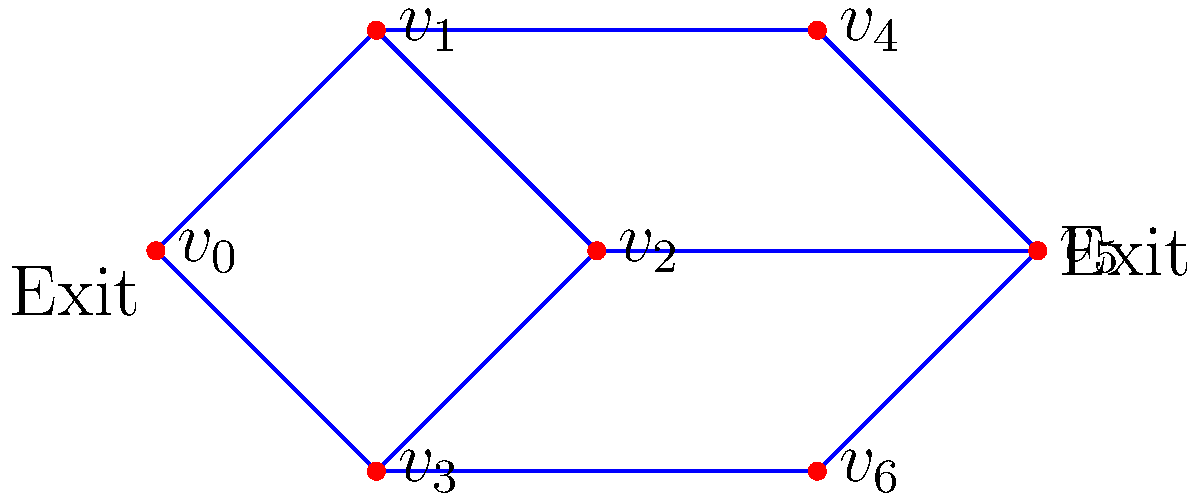Given the graph representing a shopping mall layout, where vertices represent intersections and edges represent corridors, determine the edge connectivity of the graph. How many edges need to be removed to disconnect the two emergency exits (located at $v_0$ and $v_5$)? Suggest one improvement to increase the mall's safety based on this analysis. To solve this problem, we'll follow these steps:

1. Identify the emergency exits: $v_0$ and $v_5$.

2. Determine the edge connectivity of the graph:
   - The edge connectivity is the minimum number of edges that need to be removed to disconnect the graph.
   - In this case, removing edges $(v_1, v_2)$ and $(v_2, v_5)$ would disconnect the graph.
   - Therefore, the edge connectivity of the graph is 2.

3. Find the minimum number of edges to disconnect the emergency exits:
   - We need to find the minimum number of edge-disjoint paths between $v_0$ and $v_5$.
   - Path 1: $v_0 - v_1 - v_2 - v_5$
   - Path 2: $v_0 - v_3 - v_6 - v_5$
   - There are two edge-disjoint paths, so we need to remove at least 2 edges to disconnect the exits.

4. Suggest an improvement:
   - The current edge connectivity (2) is relatively low for emergency routes.
   - To increase safety, we can add a direct corridor between $v_0$ and $v_5$.
   - This would increase the edge connectivity to 3, making the emergency exit routes more robust.
Answer: 2 edges; add direct corridor between $v_0$ and $v_5$ 